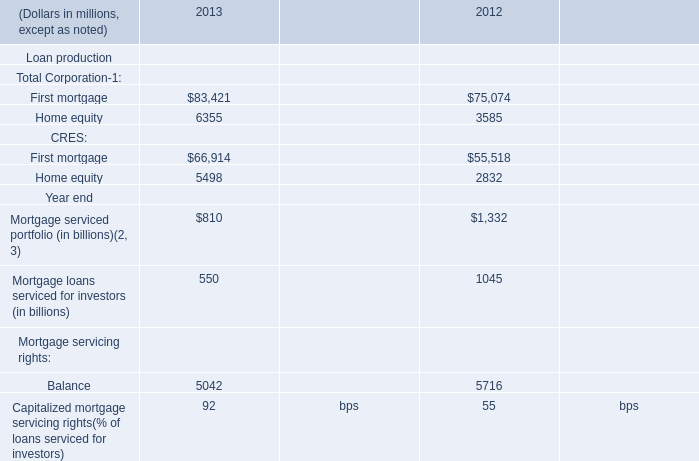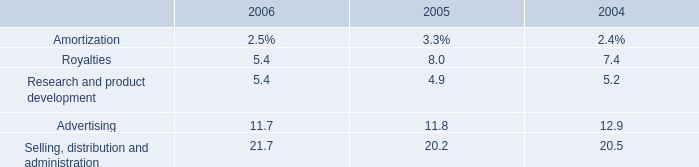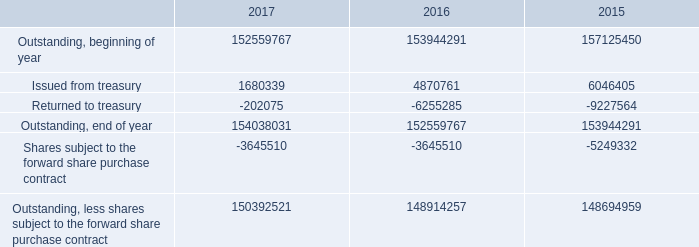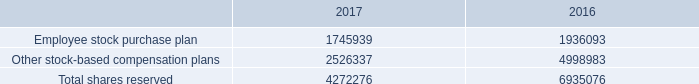What is the ratio of Issued from treasury in Table 2 to the Employee stock purchase plan in Table 3 in 2016? 
Computations: (4870761 / 1936093)
Answer: 2.51577. 